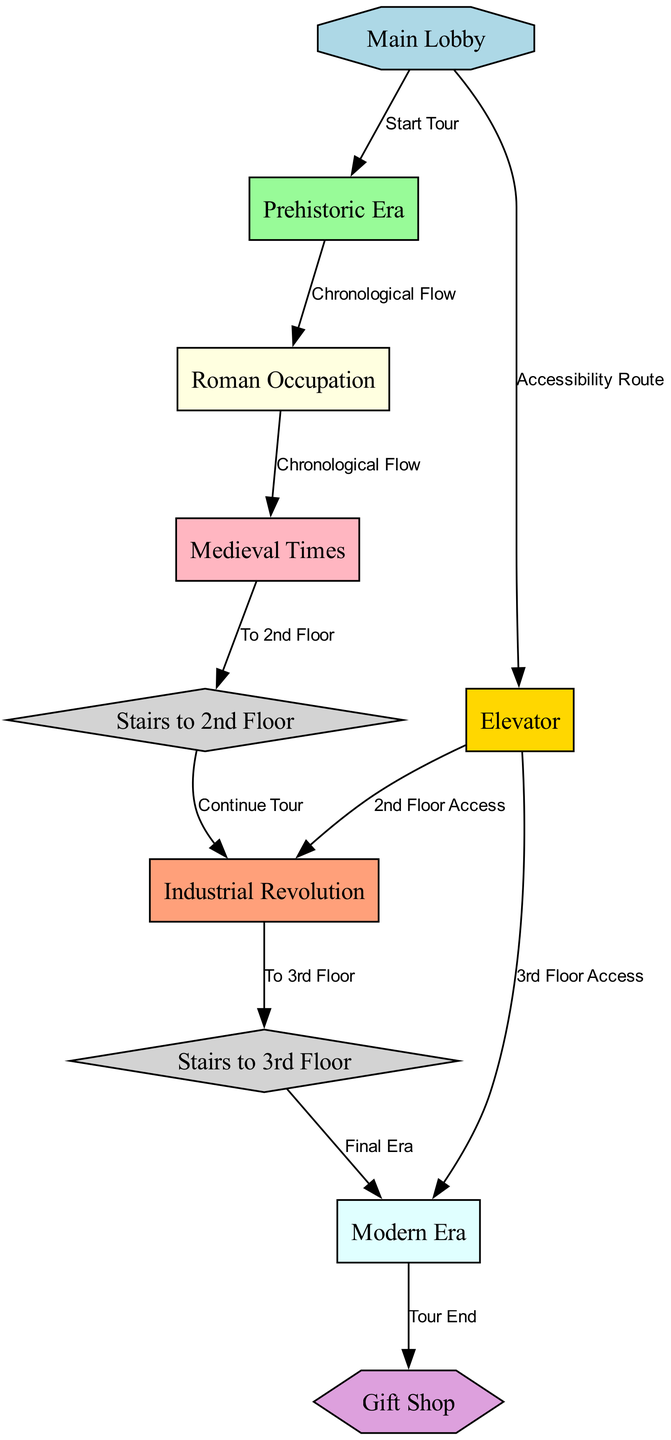What is the starting point of the tour? The starting point of the tour is indicated by the arrow from the "Main Lobby" node pointing to "Prehistoric Era". This relationship shows that visitors begin their experience in the Main Lobby and proceed to the Prehistoric section first.
Answer: Prehistoric Era How many nodes are present in the diagram? To find the number of nodes, we can count the entries listed under the "nodes" section in the data. There are ten distinct nodes representing various sections and facilities in the museum layout.
Answer: 10 What do visitors encounter after the Medieval Times exhibit? The diagram specifies that from the "Medieval Times" node, visitors move to "Stairs to 2nd Floor". This indicates that after experiencing the Medieval exhibit, visitors will take the stairs to reach the second floor of the museum.
Answer: Stairs to 2nd Floor What facility is directly accessible from the Main Lobby? From the "Main Lobby" node, the diagram shows an edge towards the "Elevator" node labeled "Accessibility Route". This indicates that the elevator facility is directly accessible from the lobby area for visitors needing assistance.
Answer: Elevator How many chronological flows are indicated in the diagram? By examining the edges connecting each exhibit node, we can see the transitions marked as "Chronological Flow". There are three such connections: from "Prehistoric Era" to "Roman Occupation", "Roman Occupation" to "Medieval Times", and "Medieval Times" to "Stairs to 2nd Floor". Thus, the total is three chronological flows.
Answer: 3 Where do visitors go after visiting the Industrial Revolution exhibit? The diagram indicates that after visiting "Industrial Revolution", visitors can move to "Stairs to 3rd Floor", as noted by the directed edge from the Industrial node to the stairs node. This means that the next logical step is to take the stairs to proceed to the third floor.
Answer: Stairs to 3rd Floor What is the ultimate destination for visitors after the Modern Era? According to the edges in the diagram, after experiencing the "Modern Era", visitors are directed to the "Gift Shop", marked as the end of their tour. This shows that the tour concludes at the gift shop, indicating where visitors can purchase memorabilia before leaving.
Answer: Gift Shop Which two ways can visitors access the second and third floors directly? The diagram shows that there are two ways to access the second floor: via the "Stairs to 2nd Floor" and the "Elevator". Similarly, access to the third floor is provided by the "Stairs to 3rd Floor" and the "Elevator". Thus, both facilities provide vertical movement options in the museum.
Answer: Stairs and Elevator 